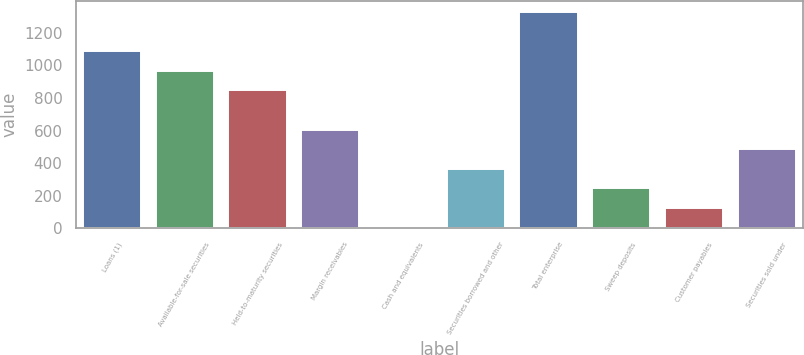<chart> <loc_0><loc_0><loc_500><loc_500><bar_chart><fcel>Loans (1)<fcel>Available-for-sale securities<fcel>Held-to-maturity securities<fcel>Margin receivables<fcel>Cash and equivalents<fcel>Securities borrowed and other<fcel>Total enterprise<fcel>Sweep deposits<fcel>Customer payables<fcel>Securities sold under<nl><fcel>1087.5<fcel>967<fcel>846.5<fcel>605.5<fcel>3<fcel>364.5<fcel>1328.5<fcel>244<fcel>123.5<fcel>485<nl></chart> 